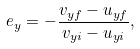<formula> <loc_0><loc_0><loc_500><loc_500>e _ { y } = - { \frac { v _ { y f } - u _ { y f } } { v _ { y i } - u _ { y i } } } ,</formula> 